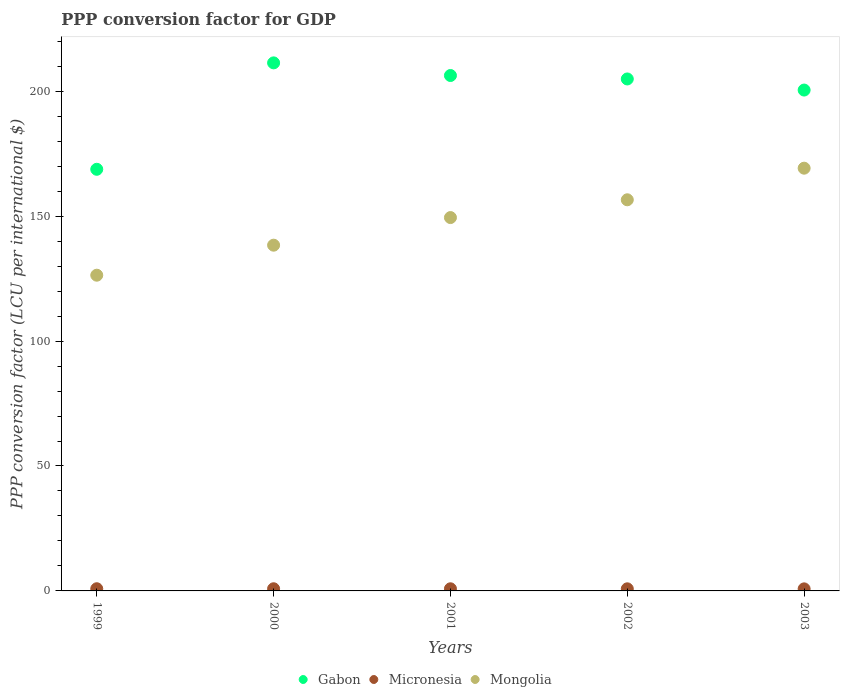How many different coloured dotlines are there?
Offer a terse response. 3. Is the number of dotlines equal to the number of legend labels?
Offer a terse response. Yes. What is the PPP conversion factor for GDP in Micronesia in 1999?
Keep it short and to the point. 0.87. Across all years, what is the maximum PPP conversion factor for GDP in Gabon?
Your answer should be compact. 211.34. Across all years, what is the minimum PPP conversion factor for GDP in Micronesia?
Offer a very short reply. 0.82. In which year was the PPP conversion factor for GDP in Mongolia maximum?
Give a very brief answer. 2003. In which year was the PPP conversion factor for GDP in Gabon minimum?
Your response must be concise. 1999. What is the total PPP conversion factor for GDP in Mongolia in the graph?
Provide a short and direct response. 739.91. What is the difference between the PPP conversion factor for GDP in Micronesia in 2000 and that in 2003?
Offer a very short reply. 0.04. What is the difference between the PPP conversion factor for GDP in Gabon in 2002 and the PPP conversion factor for GDP in Mongolia in 2000?
Give a very brief answer. 66.53. What is the average PPP conversion factor for GDP in Gabon per year?
Provide a succinct answer. 198.35. In the year 1999, what is the difference between the PPP conversion factor for GDP in Micronesia and PPP conversion factor for GDP in Gabon?
Give a very brief answer. -167.88. What is the ratio of the PPP conversion factor for GDP in Mongolia in 1999 to that in 2003?
Your answer should be compact. 0.75. Is the difference between the PPP conversion factor for GDP in Micronesia in 1999 and 2003 greater than the difference between the PPP conversion factor for GDP in Gabon in 1999 and 2003?
Make the answer very short. Yes. What is the difference between the highest and the second highest PPP conversion factor for GDP in Mongolia?
Provide a succinct answer. 12.65. What is the difference between the highest and the lowest PPP conversion factor for GDP in Mongolia?
Keep it short and to the point. 42.83. In how many years, is the PPP conversion factor for GDP in Micronesia greater than the average PPP conversion factor for GDP in Micronesia taken over all years?
Make the answer very short. 3. Is the sum of the PPP conversion factor for GDP in Micronesia in 1999 and 2003 greater than the maximum PPP conversion factor for GDP in Gabon across all years?
Your answer should be compact. No. Is the PPP conversion factor for GDP in Micronesia strictly greater than the PPP conversion factor for GDP in Gabon over the years?
Your answer should be very brief. No. Is the PPP conversion factor for GDP in Micronesia strictly less than the PPP conversion factor for GDP in Mongolia over the years?
Ensure brevity in your answer.  Yes. How many years are there in the graph?
Offer a terse response. 5. What is the difference between two consecutive major ticks on the Y-axis?
Your answer should be compact. 50. Are the values on the major ticks of Y-axis written in scientific E-notation?
Your answer should be very brief. No. Does the graph contain grids?
Offer a terse response. No. How many legend labels are there?
Your answer should be very brief. 3. What is the title of the graph?
Your answer should be compact. PPP conversion factor for GDP. Does "St. Lucia" appear as one of the legend labels in the graph?
Provide a succinct answer. No. What is the label or title of the Y-axis?
Your answer should be compact. PPP conversion factor (LCU per international $). What is the PPP conversion factor (LCU per international $) in Gabon in 1999?
Provide a succinct answer. 168.75. What is the PPP conversion factor (LCU per international $) in Micronesia in 1999?
Your answer should be compact. 0.87. What is the PPP conversion factor (LCU per international $) of Mongolia in 1999?
Give a very brief answer. 126.36. What is the PPP conversion factor (LCU per international $) in Gabon in 2000?
Give a very brief answer. 211.34. What is the PPP conversion factor (LCU per international $) in Micronesia in 2000?
Offer a very short reply. 0.86. What is the PPP conversion factor (LCU per international $) in Mongolia in 2000?
Keep it short and to the point. 138.38. What is the PPP conversion factor (LCU per international $) in Gabon in 2001?
Give a very brief answer. 206.29. What is the PPP conversion factor (LCU per international $) of Micronesia in 2001?
Your response must be concise. 0.86. What is the PPP conversion factor (LCU per international $) in Mongolia in 2001?
Your answer should be compact. 149.43. What is the PPP conversion factor (LCU per international $) of Gabon in 2002?
Give a very brief answer. 204.91. What is the PPP conversion factor (LCU per international $) of Micronesia in 2002?
Offer a very short reply. 0.84. What is the PPP conversion factor (LCU per international $) of Mongolia in 2002?
Provide a short and direct response. 156.55. What is the PPP conversion factor (LCU per international $) in Gabon in 2003?
Offer a terse response. 200.46. What is the PPP conversion factor (LCU per international $) of Micronesia in 2003?
Offer a very short reply. 0.82. What is the PPP conversion factor (LCU per international $) of Mongolia in 2003?
Provide a succinct answer. 169.2. Across all years, what is the maximum PPP conversion factor (LCU per international $) of Gabon?
Make the answer very short. 211.34. Across all years, what is the maximum PPP conversion factor (LCU per international $) of Micronesia?
Give a very brief answer. 0.87. Across all years, what is the maximum PPP conversion factor (LCU per international $) in Mongolia?
Give a very brief answer. 169.2. Across all years, what is the minimum PPP conversion factor (LCU per international $) in Gabon?
Offer a very short reply. 168.75. Across all years, what is the minimum PPP conversion factor (LCU per international $) of Micronesia?
Provide a short and direct response. 0.82. Across all years, what is the minimum PPP conversion factor (LCU per international $) in Mongolia?
Provide a succinct answer. 126.36. What is the total PPP conversion factor (LCU per international $) in Gabon in the graph?
Your answer should be very brief. 991.76. What is the total PPP conversion factor (LCU per international $) of Micronesia in the graph?
Your answer should be very brief. 4.26. What is the total PPP conversion factor (LCU per international $) in Mongolia in the graph?
Your answer should be very brief. 739.91. What is the difference between the PPP conversion factor (LCU per international $) of Gabon in 1999 and that in 2000?
Your response must be concise. -42.59. What is the difference between the PPP conversion factor (LCU per international $) of Micronesia in 1999 and that in 2000?
Ensure brevity in your answer.  0.01. What is the difference between the PPP conversion factor (LCU per international $) in Mongolia in 1999 and that in 2000?
Your answer should be compact. -12.01. What is the difference between the PPP conversion factor (LCU per international $) in Gabon in 1999 and that in 2001?
Your response must be concise. -37.53. What is the difference between the PPP conversion factor (LCU per international $) of Micronesia in 1999 and that in 2001?
Give a very brief answer. 0.02. What is the difference between the PPP conversion factor (LCU per international $) of Mongolia in 1999 and that in 2001?
Your answer should be very brief. -23.07. What is the difference between the PPP conversion factor (LCU per international $) of Gabon in 1999 and that in 2002?
Offer a terse response. -36.15. What is the difference between the PPP conversion factor (LCU per international $) in Micronesia in 1999 and that in 2002?
Give a very brief answer. 0.03. What is the difference between the PPP conversion factor (LCU per international $) in Mongolia in 1999 and that in 2002?
Your answer should be very brief. -30.18. What is the difference between the PPP conversion factor (LCU per international $) of Gabon in 1999 and that in 2003?
Provide a short and direct response. -31.71. What is the difference between the PPP conversion factor (LCU per international $) in Micronesia in 1999 and that in 2003?
Ensure brevity in your answer.  0.05. What is the difference between the PPP conversion factor (LCU per international $) of Mongolia in 1999 and that in 2003?
Offer a very short reply. -42.83. What is the difference between the PPP conversion factor (LCU per international $) in Gabon in 2000 and that in 2001?
Your answer should be very brief. 5.06. What is the difference between the PPP conversion factor (LCU per international $) in Micronesia in 2000 and that in 2001?
Offer a very short reply. 0.01. What is the difference between the PPP conversion factor (LCU per international $) of Mongolia in 2000 and that in 2001?
Keep it short and to the point. -11.05. What is the difference between the PPP conversion factor (LCU per international $) of Gabon in 2000 and that in 2002?
Make the answer very short. 6.44. What is the difference between the PPP conversion factor (LCU per international $) of Micronesia in 2000 and that in 2002?
Ensure brevity in your answer.  0.02. What is the difference between the PPP conversion factor (LCU per international $) of Mongolia in 2000 and that in 2002?
Keep it short and to the point. -18.17. What is the difference between the PPP conversion factor (LCU per international $) of Gabon in 2000 and that in 2003?
Make the answer very short. 10.88. What is the difference between the PPP conversion factor (LCU per international $) of Micronesia in 2000 and that in 2003?
Keep it short and to the point. 0.04. What is the difference between the PPP conversion factor (LCU per international $) in Mongolia in 2000 and that in 2003?
Your answer should be compact. -30.82. What is the difference between the PPP conversion factor (LCU per international $) of Gabon in 2001 and that in 2002?
Keep it short and to the point. 1.38. What is the difference between the PPP conversion factor (LCU per international $) in Micronesia in 2001 and that in 2002?
Give a very brief answer. 0.01. What is the difference between the PPP conversion factor (LCU per international $) of Mongolia in 2001 and that in 2002?
Ensure brevity in your answer.  -7.12. What is the difference between the PPP conversion factor (LCU per international $) in Gabon in 2001 and that in 2003?
Your answer should be very brief. 5.82. What is the difference between the PPP conversion factor (LCU per international $) of Micronesia in 2001 and that in 2003?
Offer a terse response. 0.03. What is the difference between the PPP conversion factor (LCU per international $) of Mongolia in 2001 and that in 2003?
Make the answer very short. -19.77. What is the difference between the PPP conversion factor (LCU per international $) in Gabon in 2002 and that in 2003?
Ensure brevity in your answer.  4.44. What is the difference between the PPP conversion factor (LCU per international $) of Micronesia in 2002 and that in 2003?
Make the answer very short. 0.02. What is the difference between the PPP conversion factor (LCU per international $) of Mongolia in 2002 and that in 2003?
Keep it short and to the point. -12.65. What is the difference between the PPP conversion factor (LCU per international $) in Gabon in 1999 and the PPP conversion factor (LCU per international $) in Micronesia in 2000?
Make the answer very short. 167.89. What is the difference between the PPP conversion factor (LCU per international $) of Gabon in 1999 and the PPP conversion factor (LCU per international $) of Mongolia in 2000?
Offer a very short reply. 30.37. What is the difference between the PPP conversion factor (LCU per international $) of Micronesia in 1999 and the PPP conversion factor (LCU per international $) of Mongolia in 2000?
Your response must be concise. -137.5. What is the difference between the PPP conversion factor (LCU per international $) in Gabon in 1999 and the PPP conversion factor (LCU per international $) in Micronesia in 2001?
Make the answer very short. 167.9. What is the difference between the PPP conversion factor (LCU per international $) in Gabon in 1999 and the PPP conversion factor (LCU per international $) in Mongolia in 2001?
Your answer should be very brief. 19.32. What is the difference between the PPP conversion factor (LCU per international $) in Micronesia in 1999 and the PPP conversion factor (LCU per international $) in Mongolia in 2001?
Offer a terse response. -148.56. What is the difference between the PPP conversion factor (LCU per international $) in Gabon in 1999 and the PPP conversion factor (LCU per international $) in Micronesia in 2002?
Ensure brevity in your answer.  167.91. What is the difference between the PPP conversion factor (LCU per international $) in Gabon in 1999 and the PPP conversion factor (LCU per international $) in Mongolia in 2002?
Give a very brief answer. 12.21. What is the difference between the PPP conversion factor (LCU per international $) of Micronesia in 1999 and the PPP conversion factor (LCU per international $) of Mongolia in 2002?
Offer a terse response. -155.67. What is the difference between the PPP conversion factor (LCU per international $) of Gabon in 1999 and the PPP conversion factor (LCU per international $) of Micronesia in 2003?
Keep it short and to the point. 167.93. What is the difference between the PPP conversion factor (LCU per international $) in Gabon in 1999 and the PPP conversion factor (LCU per international $) in Mongolia in 2003?
Ensure brevity in your answer.  -0.44. What is the difference between the PPP conversion factor (LCU per international $) in Micronesia in 1999 and the PPP conversion factor (LCU per international $) in Mongolia in 2003?
Provide a short and direct response. -168.32. What is the difference between the PPP conversion factor (LCU per international $) of Gabon in 2000 and the PPP conversion factor (LCU per international $) of Micronesia in 2001?
Offer a very short reply. 210.49. What is the difference between the PPP conversion factor (LCU per international $) in Gabon in 2000 and the PPP conversion factor (LCU per international $) in Mongolia in 2001?
Provide a succinct answer. 61.91. What is the difference between the PPP conversion factor (LCU per international $) in Micronesia in 2000 and the PPP conversion factor (LCU per international $) in Mongolia in 2001?
Your answer should be compact. -148.57. What is the difference between the PPP conversion factor (LCU per international $) in Gabon in 2000 and the PPP conversion factor (LCU per international $) in Micronesia in 2002?
Your response must be concise. 210.5. What is the difference between the PPP conversion factor (LCU per international $) of Gabon in 2000 and the PPP conversion factor (LCU per international $) of Mongolia in 2002?
Your answer should be very brief. 54.8. What is the difference between the PPP conversion factor (LCU per international $) in Micronesia in 2000 and the PPP conversion factor (LCU per international $) in Mongolia in 2002?
Provide a succinct answer. -155.68. What is the difference between the PPP conversion factor (LCU per international $) in Gabon in 2000 and the PPP conversion factor (LCU per international $) in Micronesia in 2003?
Keep it short and to the point. 210.52. What is the difference between the PPP conversion factor (LCU per international $) of Gabon in 2000 and the PPP conversion factor (LCU per international $) of Mongolia in 2003?
Ensure brevity in your answer.  42.15. What is the difference between the PPP conversion factor (LCU per international $) of Micronesia in 2000 and the PPP conversion factor (LCU per international $) of Mongolia in 2003?
Your response must be concise. -168.33. What is the difference between the PPP conversion factor (LCU per international $) in Gabon in 2001 and the PPP conversion factor (LCU per international $) in Micronesia in 2002?
Offer a very short reply. 205.44. What is the difference between the PPP conversion factor (LCU per international $) in Gabon in 2001 and the PPP conversion factor (LCU per international $) in Mongolia in 2002?
Give a very brief answer. 49.74. What is the difference between the PPP conversion factor (LCU per international $) of Micronesia in 2001 and the PPP conversion factor (LCU per international $) of Mongolia in 2002?
Offer a terse response. -155.69. What is the difference between the PPP conversion factor (LCU per international $) in Gabon in 2001 and the PPP conversion factor (LCU per international $) in Micronesia in 2003?
Give a very brief answer. 205.46. What is the difference between the PPP conversion factor (LCU per international $) of Gabon in 2001 and the PPP conversion factor (LCU per international $) of Mongolia in 2003?
Give a very brief answer. 37.09. What is the difference between the PPP conversion factor (LCU per international $) of Micronesia in 2001 and the PPP conversion factor (LCU per international $) of Mongolia in 2003?
Offer a very short reply. -168.34. What is the difference between the PPP conversion factor (LCU per international $) in Gabon in 2002 and the PPP conversion factor (LCU per international $) in Micronesia in 2003?
Offer a very short reply. 204.08. What is the difference between the PPP conversion factor (LCU per international $) of Gabon in 2002 and the PPP conversion factor (LCU per international $) of Mongolia in 2003?
Keep it short and to the point. 35.71. What is the difference between the PPP conversion factor (LCU per international $) of Micronesia in 2002 and the PPP conversion factor (LCU per international $) of Mongolia in 2003?
Give a very brief answer. -168.35. What is the average PPP conversion factor (LCU per international $) of Gabon per year?
Your answer should be very brief. 198.35. What is the average PPP conversion factor (LCU per international $) of Micronesia per year?
Provide a succinct answer. 0.85. What is the average PPP conversion factor (LCU per international $) in Mongolia per year?
Provide a short and direct response. 147.98. In the year 1999, what is the difference between the PPP conversion factor (LCU per international $) of Gabon and PPP conversion factor (LCU per international $) of Micronesia?
Offer a terse response. 167.88. In the year 1999, what is the difference between the PPP conversion factor (LCU per international $) of Gabon and PPP conversion factor (LCU per international $) of Mongolia?
Keep it short and to the point. 42.39. In the year 1999, what is the difference between the PPP conversion factor (LCU per international $) in Micronesia and PPP conversion factor (LCU per international $) in Mongolia?
Make the answer very short. -125.49. In the year 2000, what is the difference between the PPP conversion factor (LCU per international $) in Gabon and PPP conversion factor (LCU per international $) in Micronesia?
Make the answer very short. 210.48. In the year 2000, what is the difference between the PPP conversion factor (LCU per international $) in Gabon and PPP conversion factor (LCU per international $) in Mongolia?
Make the answer very short. 72.97. In the year 2000, what is the difference between the PPP conversion factor (LCU per international $) in Micronesia and PPP conversion factor (LCU per international $) in Mongolia?
Your answer should be compact. -137.51. In the year 2001, what is the difference between the PPP conversion factor (LCU per international $) of Gabon and PPP conversion factor (LCU per international $) of Micronesia?
Provide a short and direct response. 205.43. In the year 2001, what is the difference between the PPP conversion factor (LCU per international $) of Gabon and PPP conversion factor (LCU per international $) of Mongolia?
Give a very brief answer. 56.86. In the year 2001, what is the difference between the PPP conversion factor (LCU per international $) of Micronesia and PPP conversion factor (LCU per international $) of Mongolia?
Your response must be concise. -148.58. In the year 2002, what is the difference between the PPP conversion factor (LCU per international $) in Gabon and PPP conversion factor (LCU per international $) in Micronesia?
Ensure brevity in your answer.  204.06. In the year 2002, what is the difference between the PPP conversion factor (LCU per international $) of Gabon and PPP conversion factor (LCU per international $) of Mongolia?
Your answer should be very brief. 48.36. In the year 2002, what is the difference between the PPP conversion factor (LCU per international $) in Micronesia and PPP conversion factor (LCU per international $) in Mongolia?
Your response must be concise. -155.7. In the year 2003, what is the difference between the PPP conversion factor (LCU per international $) in Gabon and PPP conversion factor (LCU per international $) in Micronesia?
Your answer should be very brief. 199.64. In the year 2003, what is the difference between the PPP conversion factor (LCU per international $) in Gabon and PPP conversion factor (LCU per international $) in Mongolia?
Your answer should be compact. 31.27. In the year 2003, what is the difference between the PPP conversion factor (LCU per international $) in Micronesia and PPP conversion factor (LCU per international $) in Mongolia?
Make the answer very short. -168.37. What is the ratio of the PPP conversion factor (LCU per international $) in Gabon in 1999 to that in 2000?
Offer a very short reply. 0.8. What is the ratio of the PPP conversion factor (LCU per international $) of Micronesia in 1999 to that in 2000?
Offer a terse response. 1.01. What is the ratio of the PPP conversion factor (LCU per international $) of Mongolia in 1999 to that in 2000?
Make the answer very short. 0.91. What is the ratio of the PPP conversion factor (LCU per international $) of Gabon in 1999 to that in 2001?
Offer a terse response. 0.82. What is the ratio of the PPP conversion factor (LCU per international $) of Micronesia in 1999 to that in 2001?
Make the answer very short. 1.02. What is the ratio of the PPP conversion factor (LCU per international $) of Mongolia in 1999 to that in 2001?
Offer a terse response. 0.85. What is the ratio of the PPP conversion factor (LCU per international $) of Gabon in 1999 to that in 2002?
Keep it short and to the point. 0.82. What is the ratio of the PPP conversion factor (LCU per international $) of Mongolia in 1999 to that in 2002?
Make the answer very short. 0.81. What is the ratio of the PPP conversion factor (LCU per international $) of Gabon in 1999 to that in 2003?
Offer a terse response. 0.84. What is the ratio of the PPP conversion factor (LCU per international $) in Micronesia in 1999 to that in 2003?
Offer a very short reply. 1.06. What is the ratio of the PPP conversion factor (LCU per international $) of Mongolia in 1999 to that in 2003?
Provide a short and direct response. 0.75. What is the ratio of the PPP conversion factor (LCU per international $) in Gabon in 2000 to that in 2001?
Your response must be concise. 1.02. What is the ratio of the PPP conversion factor (LCU per international $) of Micronesia in 2000 to that in 2001?
Offer a terse response. 1.01. What is the ratio of the PPP conversion factor (LCU per international $) of Mongolia in 2000 to that in 2001?
Give a very brief answer. 0.93. What is the ratio of the PPP conversion factor (LCU per international $) of Gabon in 2000 to that in 2002?
Give a very brief answer. 1.03. What is the ratio of the PPP conversion factor (LCU per international $) in Micronesia in 2000 to that in 2002?
Your answer should be compact. 1.03. What is the ratio of the PPP conversion factor (LCU per international $) in Mongolia in 2000 to that in 2002?
Provide a succinct answer. 0.88. What is the ratio of the PPP conversion factor (LCU per international $) in Gabon in 2000 to that in 2003?
Make the answer very short. 1.05. What is the ratio of the PPP conversion factor (LCU per international $) of Micronesia in 2000 to that in 2003?
Your answer should be compact. 1.05. What is the ratio of the PPP conversion factor (LCU per international $) of Mongolia in 2000 to that in 2003?
Your answer should be compact. 0.82. What is the ratio of the PPP conversion factor (LCU per international $) in Micronesia in 2001 to that in 2002?
Give a very brief answer. 1.02. What is the ratio of the PPP conversion factor (LCU per international $) of Mongolia in 2001 to that in 2002?
Give a very brief answer. 0.95. What is the ratio of the PPP conversion factor (LCU per international $) in Micronesia in 2001 to that in 2003?
Your response must be concise. 1.04. What is the ratio of the PPP conversion factor (LCU per international $) of Mongolia in 2001 to that in 2003?
Ensure brevity in your answer.  0.88. What is the ratio of the PPP conversion factor (LCU per international $) in Gabon in 2002 to that in 2003?
Make the answer very short. 1.02. What is the ratio of the PPP conversion factor (LCU per international $) in Micronesia in 2002 to that in 2003?
Provide a succinct answer. 1.02. What is the ratio of the PPP conversion factor (LCU per international $) in Mongolia in 2002 to that in 2003?
Your response must be concise. 0.93. What is the difference between the highest and the second highest PPP conversion factor (LCU per international $) of Gabon?
Provide a succinct answer. 5.06. What is the difference between the highest and the second highest PPP conversion factor (LCU per international $) in Micronesia?
Give a very brief answer. 0.01. What is the difference between the highest and the second highest PPP conversion factor (LCU per international $) of Mongolia?
Your answer should be very brief. 12.65. What is the difference between the highest and the lowest PPP conversion factor (LCU per international $) of Gabon?
Offer a terse response. 42.59. What is the difference between the highest and the lowest PPP conversion factor (LCU per international $) of Micronesia?
Provide a succinct answer. 0.05. What is the difference between the highest and the lowest PPP conversion factor (LCU per international $) in Mongolia?
Offer a terse response. 42.83. 